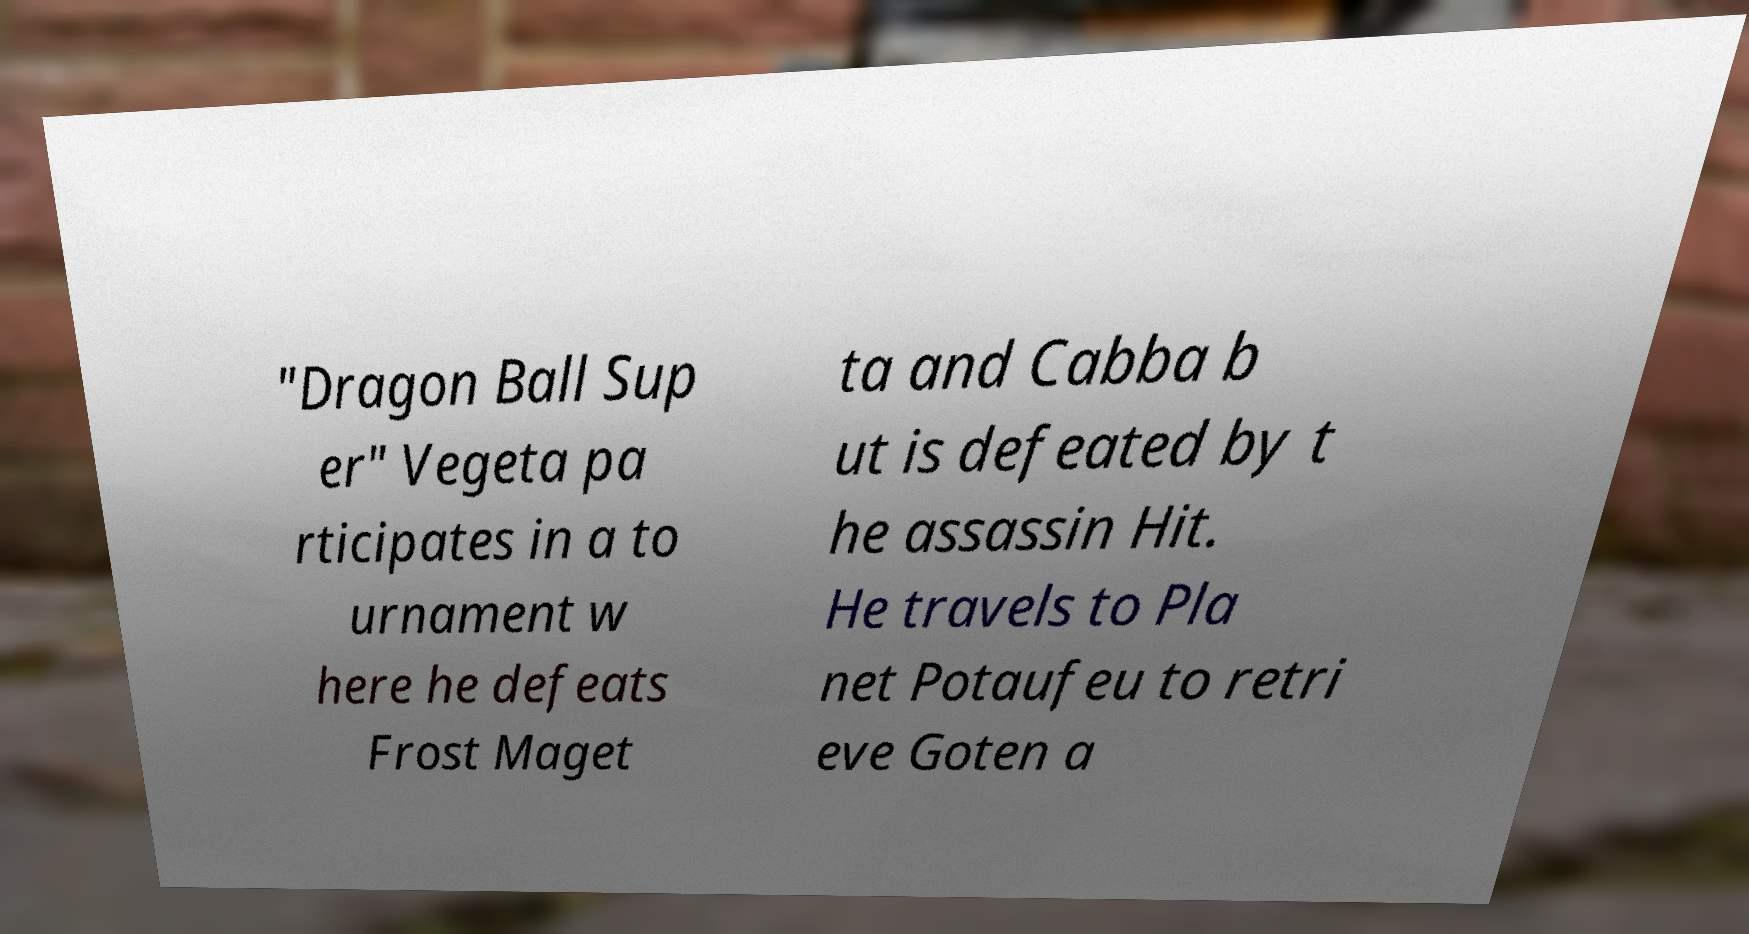Please read and relay the text visible in this image. What does it say? "Dragon Ball Sup er" Vegeta pa rticipates in a to urnament w here he defeats Frost Maget ta and Cabba b ut is defeated by t he assassin Hit. He travels to Pla net Potaufeu to retri eve Goten a 